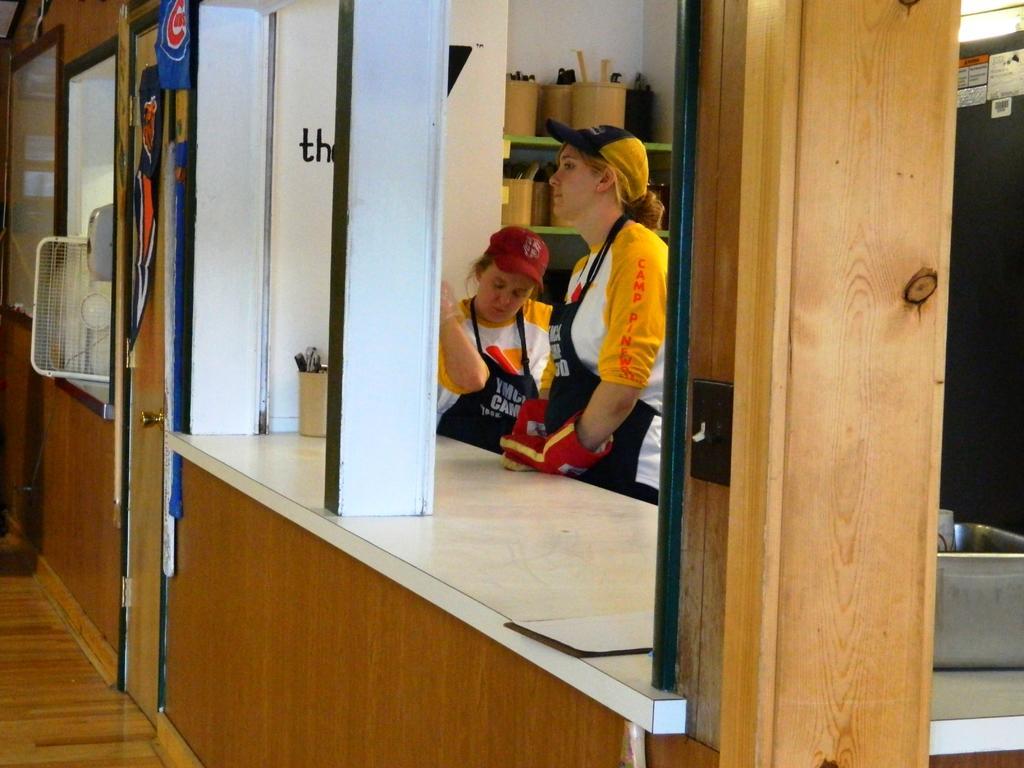Please provide a concise description of this image. In this image we can see inside of a house. There are few people in the image. There is a fan in the image. There are few objects at the right side of the image. There are many objects on the shelves. There are many objects in the image. 